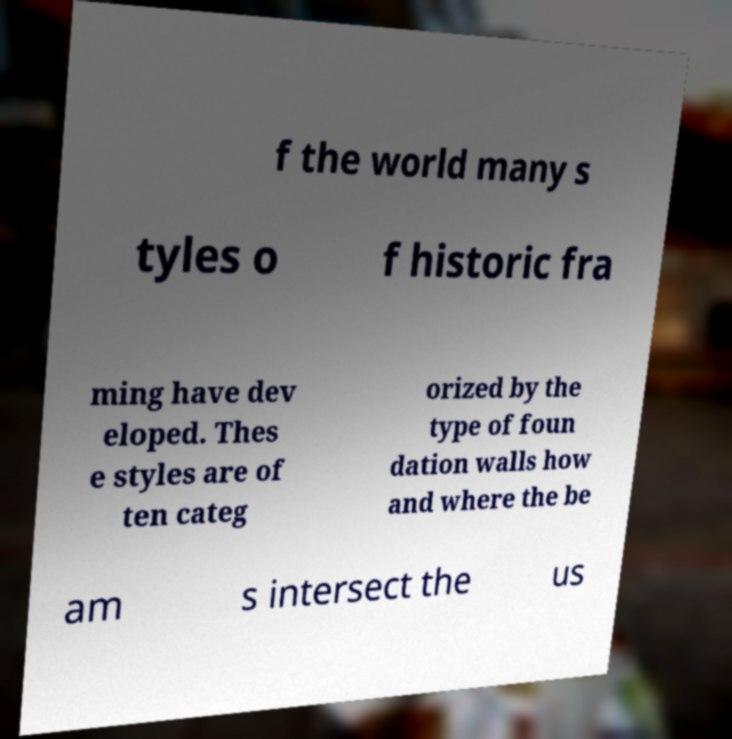I need the written content from this picture converted into text. Can you do that? f the world many s tyles o f historic fra ming have dev eloped. Thes e styles are of ten categ orized by the type of foun dation walls how and where the be am s intersect the us 